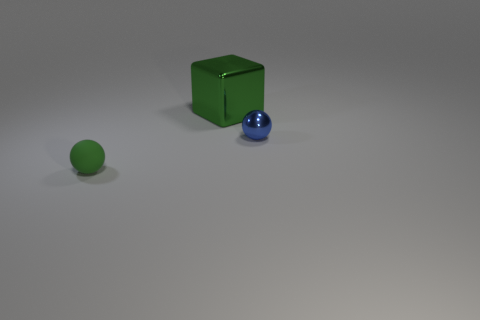How does the lighting in the scene affect the objects? The lighting creates subtle shadows and highlights that help define the shapes of the objects, giving the scene depth and dimension. The green block and sphere cast soft shadows onto the surface, while the blue sphere reflects light, showcasing its glossy characteristics. 